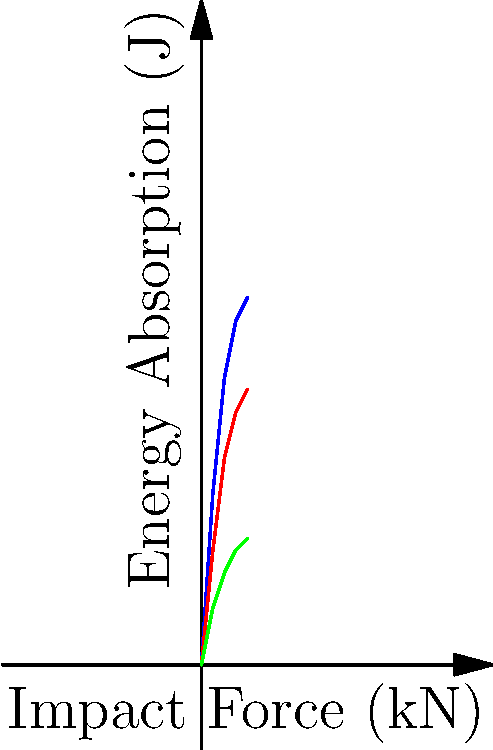Based on the graph showing the energy absorption capabilities of three different protective gear materials under varying impact forces, which material would you recommend for a high-impact sports application where maximum energy absorption is crucial? To determine the best material for high-impact sports applications, we need to analyze the energy absorption capabilities of each material as the impact force increases:

1. Material A (blue line):
   - Shows the highest energy absorption across all impact forces
   - Reaches approximately 32 J at 4 kN impact force
   - Has the steepest curve, indicating rapid energy absorption increase

2. Material B (red line):
   - Shows moderate energy absorption
   - Reaches approximately 24 J at 4 kN impact force
   - Has a less steep curve compared to Material A

3. Material C (green line):
   - Shows the lowest energy absorption among the three materials
   - Reaches only about 11 J at 4 kN impact force
   - Has the least steep curve, indicating slower energy absorption increase

For high-impact sports applications where maximum energy absorption is crucial, we want the material that can absorb the most energy at high impact forces. This helps to reduce the force transmitted to the athlete's body, potentially preventing injuries.

Material A clearly outperforms the other two materials in terms of energy absorption, especially at higher impact forces. It consistently absorbs more energy than Materials B and C across the entire range of impact forces shown.

Therefore, Material A would be the best choice for high-impact sports applications requiring maximum energy absorption.
Answer: Material A 